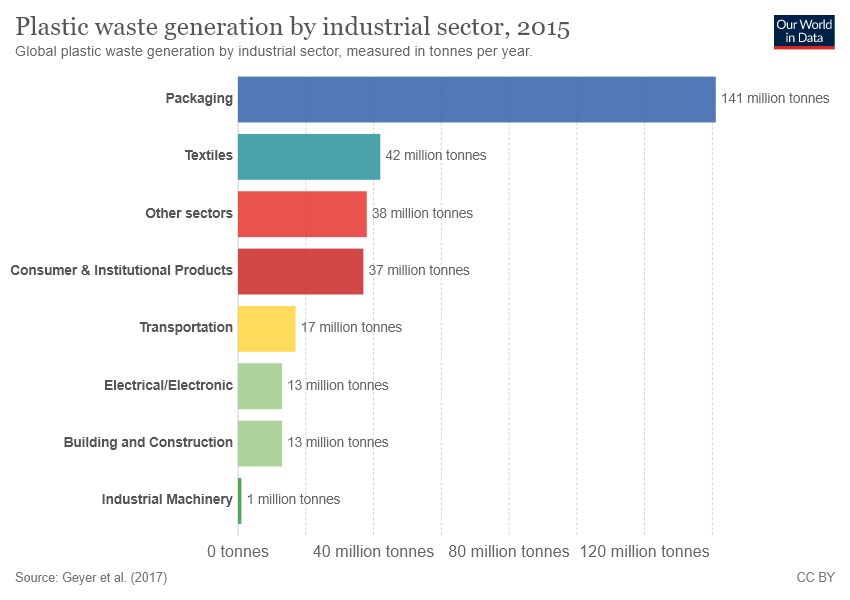Give some essential details in this illustration. The sum of the smallest two bars is not greater than the value of the third largest bar. What is the value of the yellow bar? It is 17.. 